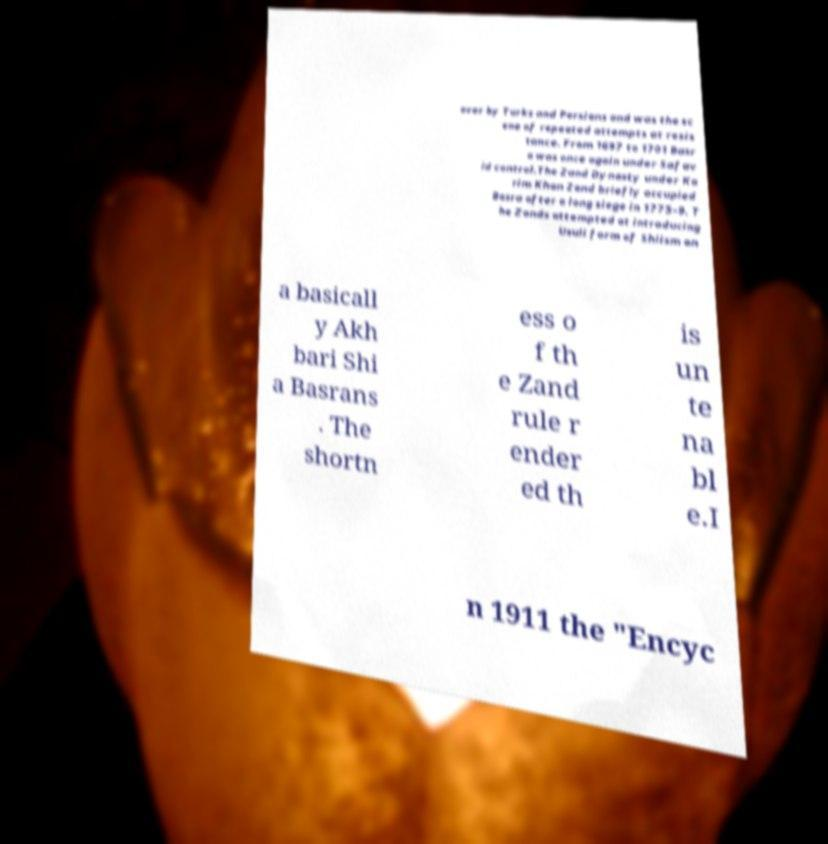For documentation purposes, I need the text within this image transcribed. Could you provide that? over by Turks and Persians and was the sc ene of repeated attempts at resis tance. From 1697 to 1701 Basr a was once again under Safav id control.The Zand Dynasty under Ka rim Khan Zand briefly occupied Basra after a long siege in 1775–9. T he Zands attempted at introducing Usuli form of Shiism on a basicall y Akh bari Shi a Basrans . The shortn ess o f th e Zand rule r ender ed th is un te na bl e.I n 1911 the "Encyc 